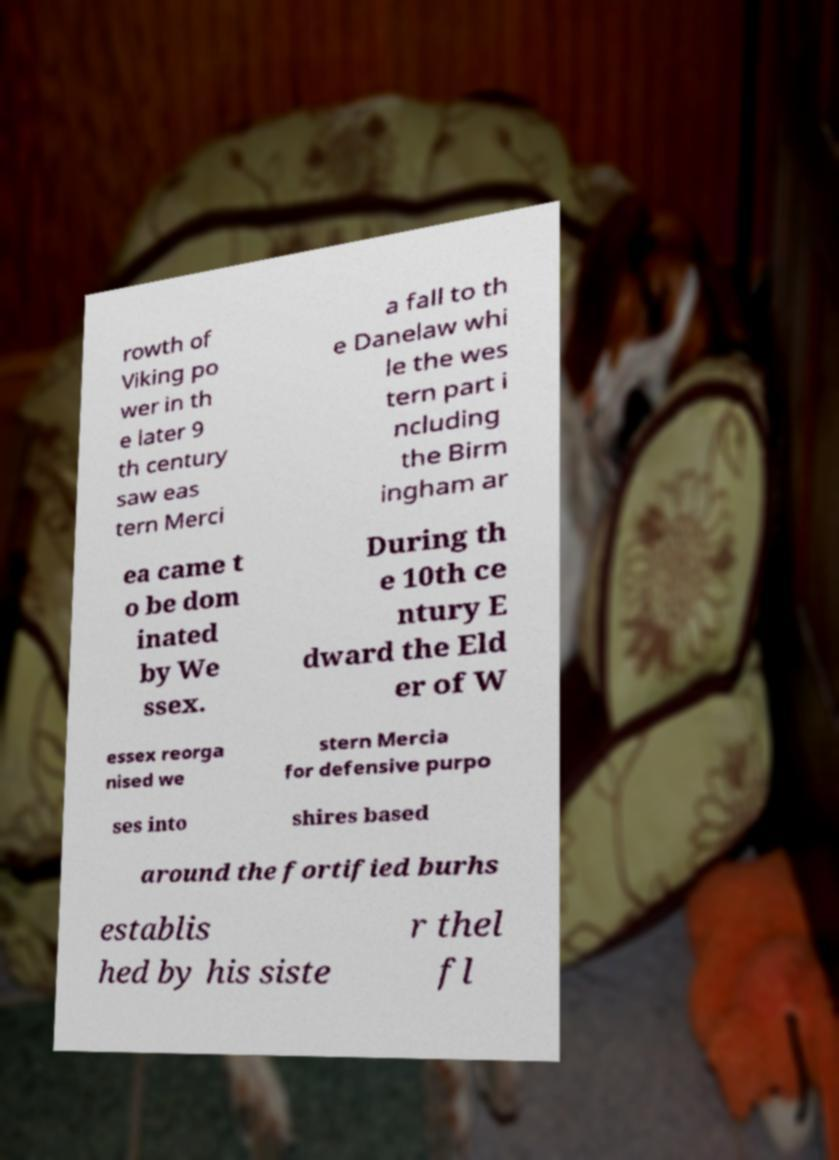There's text embedded in this image that I need extracted. Can you transcribe it verbatim? rowth of Viking po wer in th e later 9 th century saw eas tern Merci a fall to th e Danelaw whi le the wes tern part i ncluding the Birm ingham ar ea came t o be dom inated by We ssex. During th e 10th ce ntury E dward the Eld er of W essex reorga nised we stern Mercia for defensive purpo ses into shires based around the fortified burhs establis hed by his siste r thel fl 